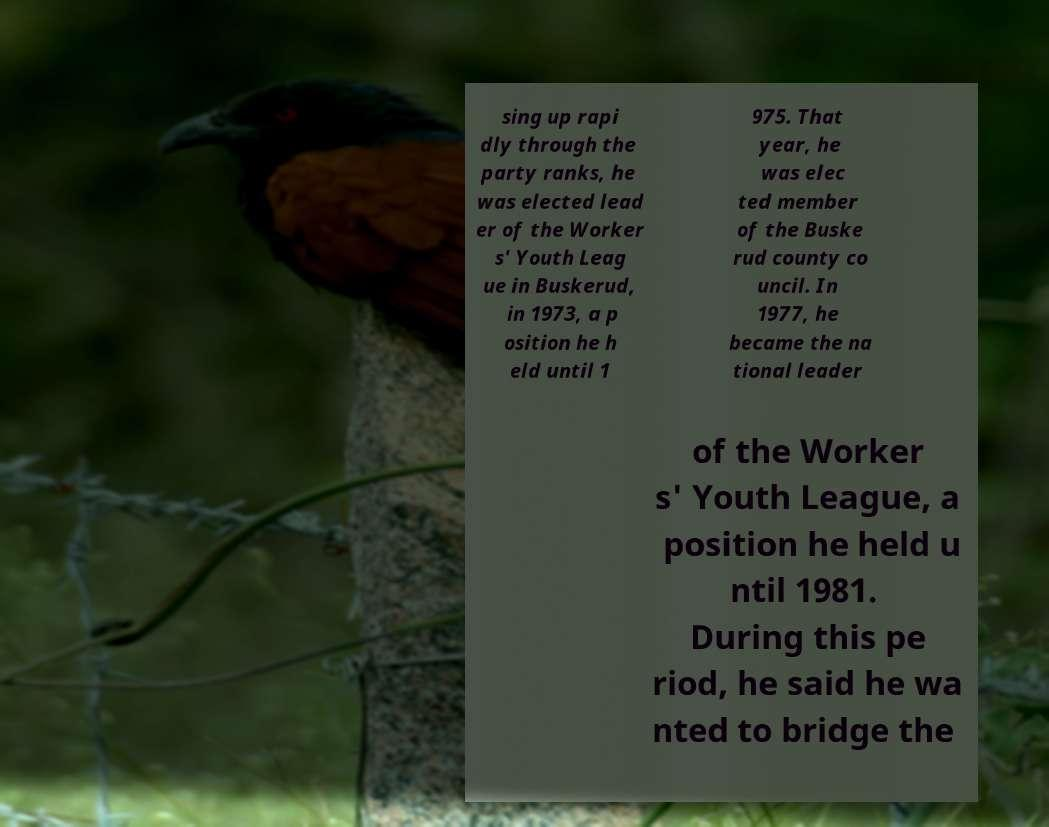Can you accurately transcribe the text from the provided image for me? sing up rapi dly through the party ranks, he was elected lead er of the Worker s' Youth Leag ue in Buskerud, in 1973, a p osition he h eld until 1 975. That year, he was elec ted member of the Buske rud county co uncil. In 1977, he became the na tional leader of the Worker s' Youth League, a position he held u ntil 1981. During this pe riod, he said he wa nted to bridge the 